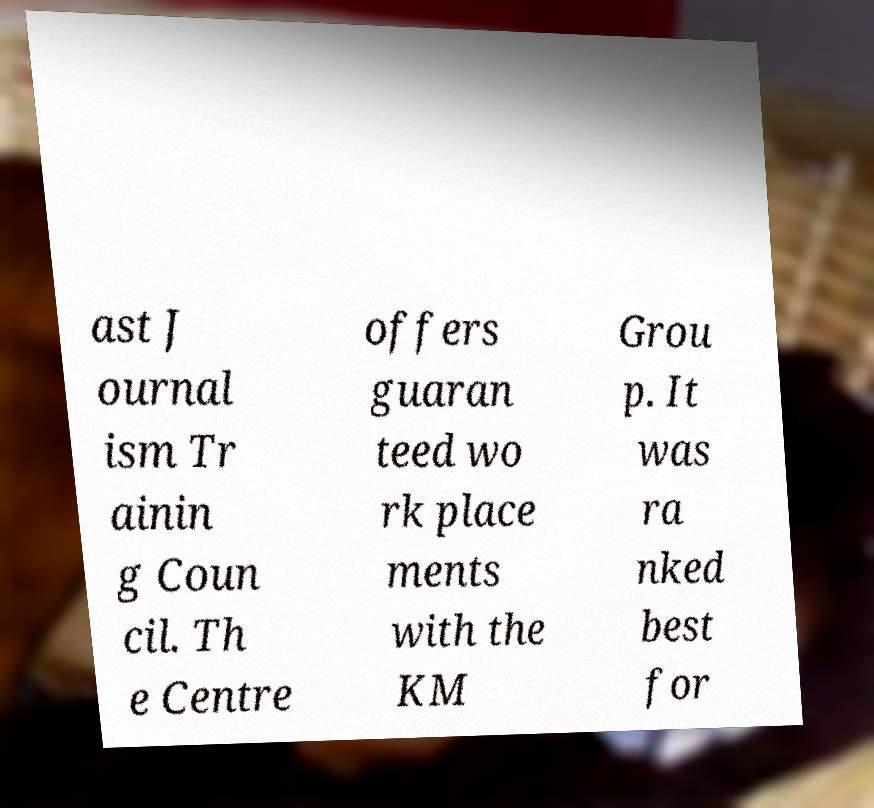Please identify and transcribe the text found in this image. ast J ournal ism Tr ainin g Coun cil. Th e Centre offers guaran teed wo rk place ments with the KM Grou p. It was ra nked best for 